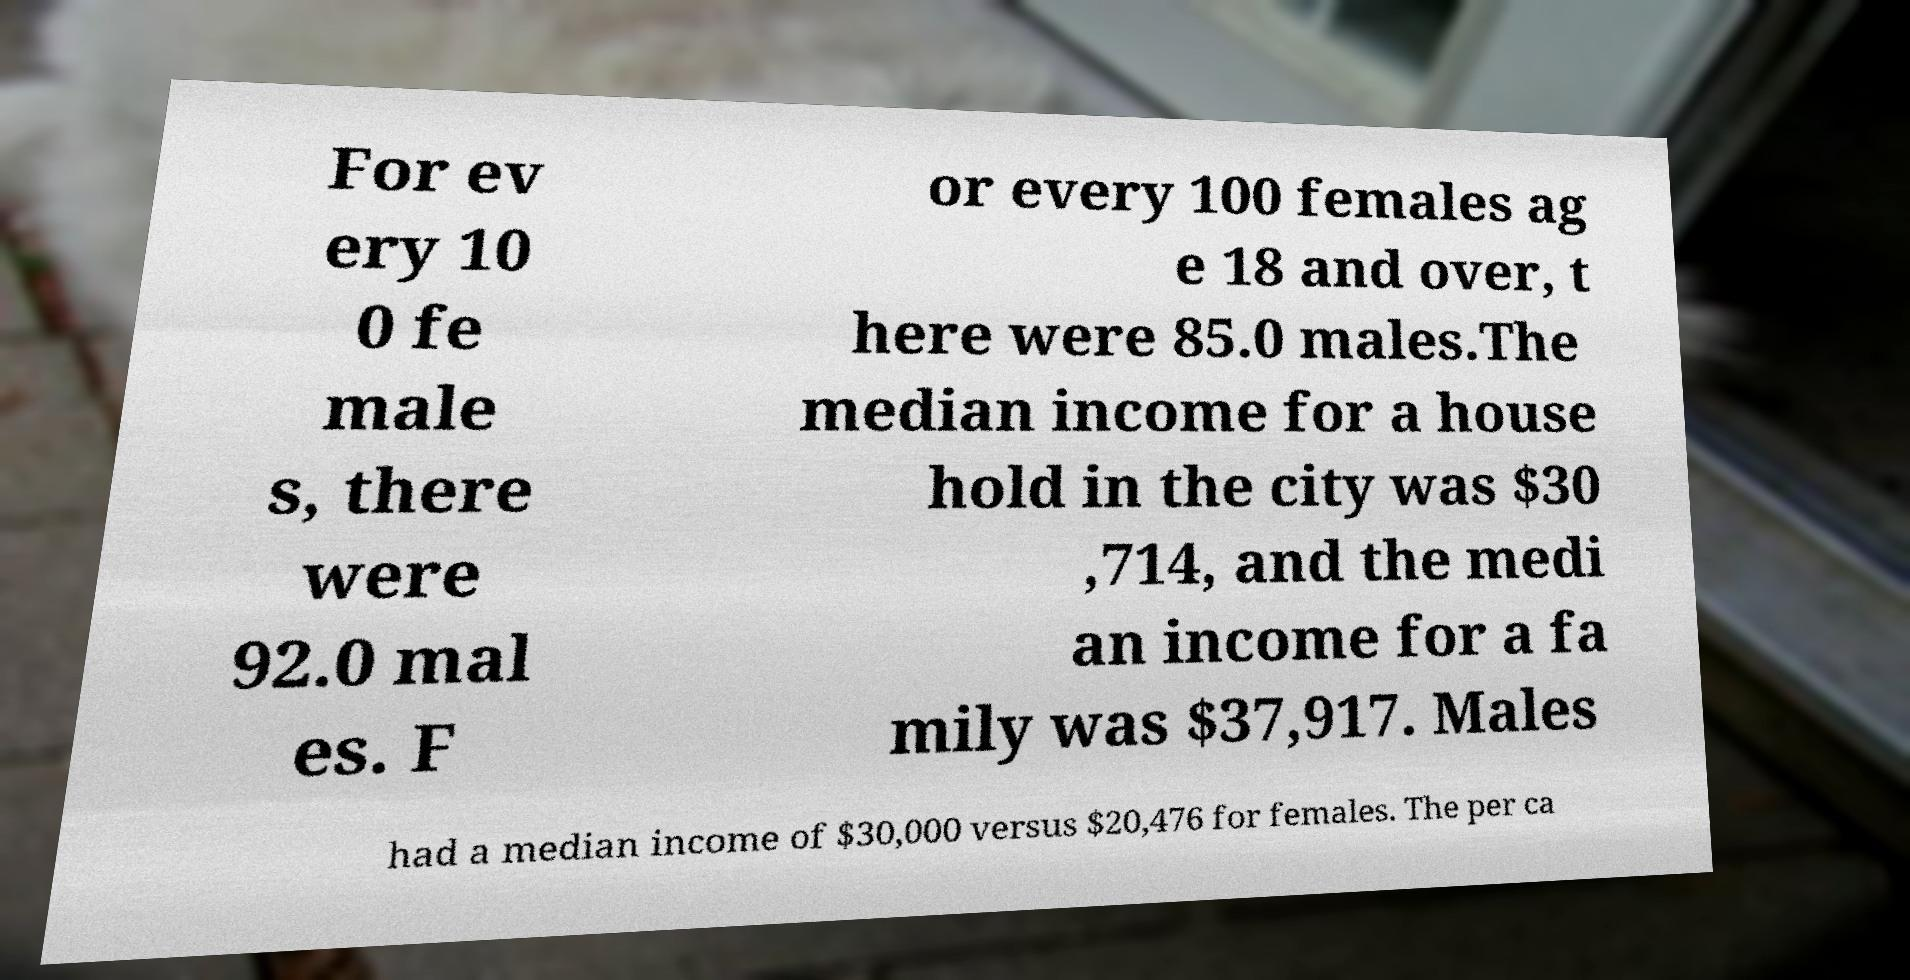I need the written content from this picture converted into text. Can you do that? For ev ery 10 0 fe male s, there were 92.0 mal es. F or every 100 females ag e 18 and over, t here were 85.0 males.The median income for a house hold in the city was $30 ,714, and the medi an income for a fa mily was $37,917. Males had a median income of $30,000 versus $20,476 for females. The per ca 